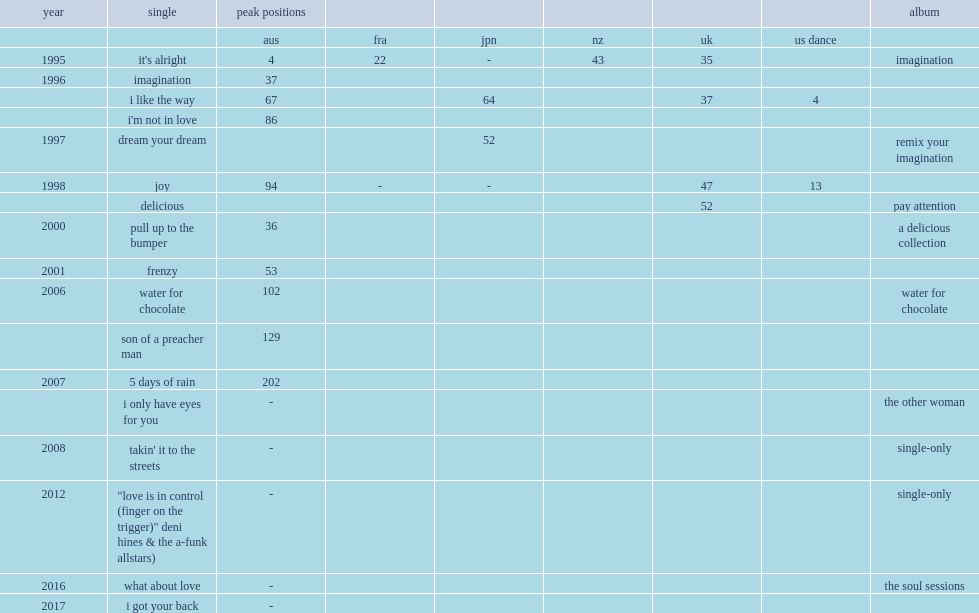Which album of deni hines's was released with the single "what about love" in 2016? The soul sessions. 